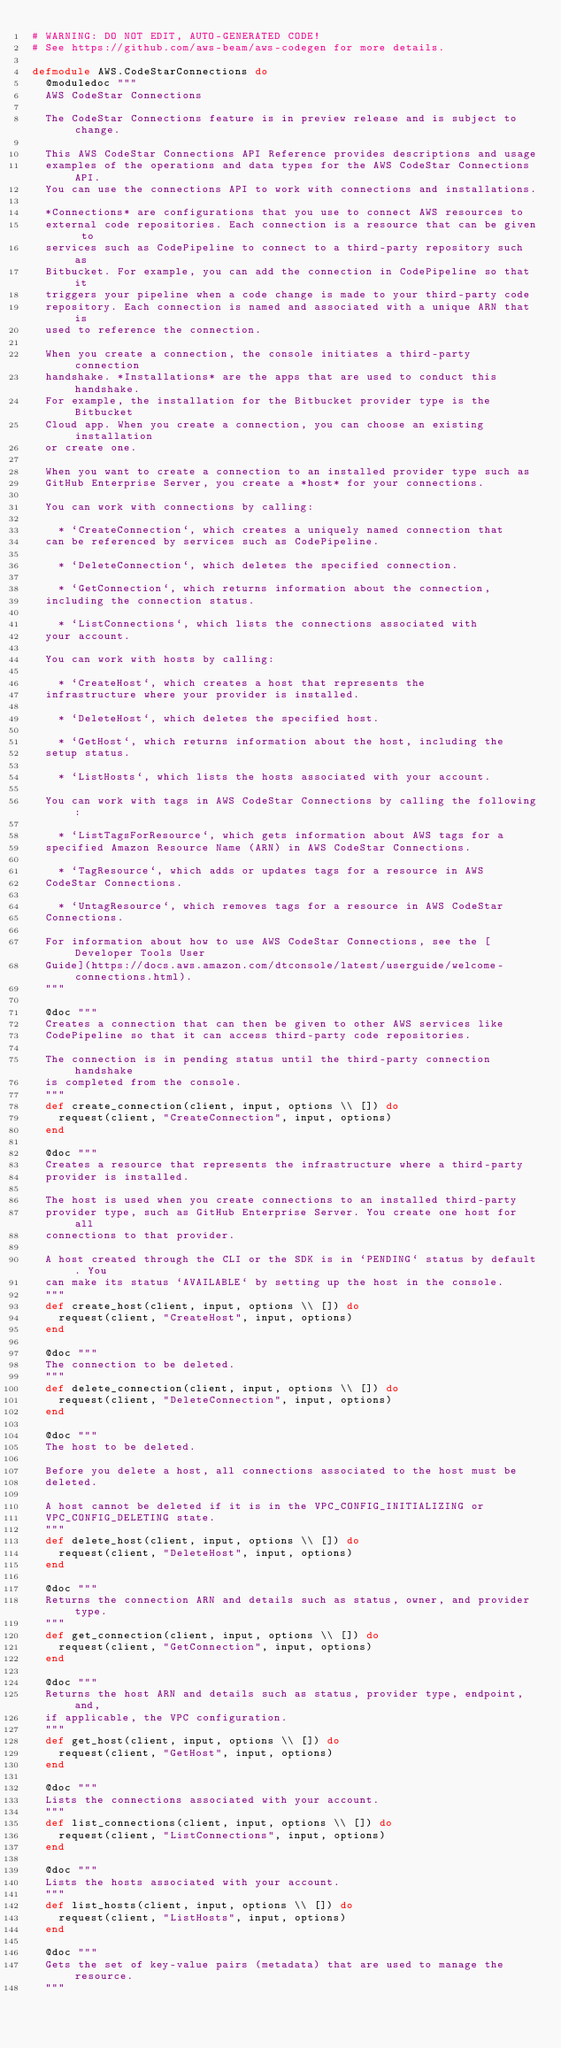<code> <loc_0><loc_0><loc_500><loc_500><_Elixir_># WARNING: DO NOT EDIT, AUTO-GENERATED CODE!
# See https://github.com/aws-beam/aws-codegen for more details.

defmodule AWS.CodeStarConnections do
  @moduledoc """
  AWS CodeStar Connections

  The CodeStar Connections feature is in preview release and is subject to change.

  This AWS CodeStar Connections API Reference provides descriptions and usage
  examples of the operations and data types for the AWS CodeStar Connections API.
  You can use the connections API to work with connections and installations.

  *Connections* are configurations that you use to connect AWS resources to
  external code repositories. Each connection is a resource that can be given to
  services such as CodePipeline to connect to a third-party repository such as
  Bitbucket. For example, you can add the connection in CodePipeline so that it
  triggers your pipeline when a code change is made to your third-party code
  repository. Each connection is named and associated with a unique ARN that is
  used to reference the connection.

  When you create a connection, the console initiates a third-party connection
  handshake. *Installations* are the apps that are used to conduct this handshake.
  For example, the installation for the Bitbucket provider type is the Bitbucket
  Cloud app. When you create a connection, you can choose an existing installation
  or create one.

  When you want to create a connection to an installed provider type such as
  GitHub Enterprise Server, you create a *host* for your connections.

  You can work with connections by calling:

    * `CreateConnection`, which creates a uniquely named connection that
  can be referenced by services such as CodePipeline.

    * `DeleteConnection`, which deletes the specified connection.

    * `GetConnection`, which returns information about the connection,
  including the connection status.

    * `ListConnections`, which lists the connections associated with
  your account.

  You can work with hosts by calling:

    * `CreateHost`, which creates a host that represents the
  infrastructure where your provider is installed.

    * `DeleteHost`, which deletes the specified host.

    * `GetHost`, which returns information about the host, including the
  setup status.

    * `ListHosts`, which lists the hosts associated with your account.

  You can work with tags in AWS CodeStar Connections by calling the following:

    * `ListTagsForResource`, which gets information about AWS tags for a
  specified Amazon Resource Name (ARN) in AWS CodeStar Connections.

    * `TagResource`, which adds or updates tags for a resource in AWS
  CodeStar Connections.

    * `UntagResource`, which removes tags for a resource in AWS CodeStar
  Connections.

  For information about how to use AWS CodeStar Connections, see the [Developer Tools User
  Guide](https://docs.aws.amazon.com/dtconsole/latest/userguide/welcome-connections.html).
  """

  @doc """
  Creates a connection that can then be given to other AWS services like
  CodePipeline so that it can access third-party code repositories.

  The connection is in pending status until the third-party connection handshake
  is completed from the console.
  """
  def create_connection(client, input, options \\ []) do
    request(client, "CreateConnection", input, options)
  end

  @doc """
  Creates a resource that represents the infrastructure where a third-party
  provider is installed.

  The host is used when you create connections to an installed third-party
  provider type, such as GitHub Enterprise Server. You create one host for all
  connections to that provider.

  A host created through the CLI or the SDK is in `PENDING` status by default. You
  can make its status `AVAILABLE` by setting up the host in the console.
  """
  def create_host(client, input, options \\ []) do
    request(client, "CreateHost", input, options)
  end

  @doc """
  The connection to be deleted.
  """
  def delete_connection(client, input, options \\ []) do
    request(client, "DeleteConnection", input, options)
  end

  @doc """
  The host to be deleted.

  Before you delete a host, all connections associated to the host must be
  deleted.

  A host cannot be deleted if it is in the VPC_CONFIG_INITIALIZING or
  VPC_CONFIG_DELETING state.
  """
  def delete_host(client, input, options \\ []) do
    request(client, "DeleteHost", input, options)
  end

  @doc """
  Returns the connection ARN and details such as status, owner, and provider type.
  """
  def get_connection(client, input, options \\ []) do
    request(client, "GetConnection", input, options)
  end

  @doc """
  Returns the host ARN and details such as status, provider type, endpoint, and,
  if applicable, the VPC configuration.
  """
  def get_host(client, input, options \\ []) do
    request(client, "GetHost", input, options)
  end

  @doc """
  Lists the connections associated with your account.
  """
  def list_connections(client, input, options \\ []) do
    request(client, "ListConnections", input, options)
  end

  @doc """
  Lists the hosts associated with your account.
  """
  def list_hosts(client, input, options \\ []) do
    request(client, "ListHosts", input, options)
  end

  @doc """
  Gets the set of key-value pairs (metadata) that are used to manage the resource.
  """</code> 